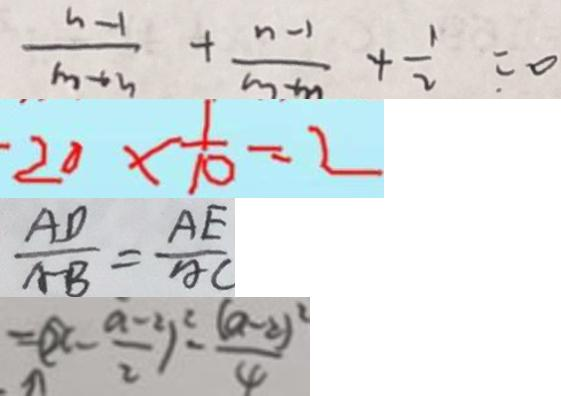Convert formula to latex. <formula><loc_0><loc_0><loc_500><loc_500>\frac { n - 1 } { n + 3 } + \frac { n - 1 } { m + m } + \frac { 1 } { 2 } = 0 
 2 0 \times \frac { 1 } { 1 0 } = 2 
 \frac { A D } { A B } = \frac { A E } { A C } 
 = ( x - \frac { a - 2 } { 2 } ) ^ { 2 } - \frac { ( a - 2 ) ^ { 2 } } { 4 }</formula> 